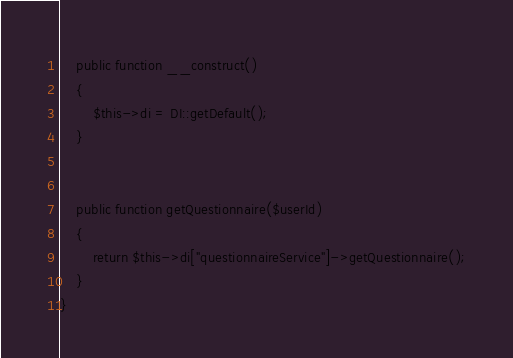<code> <loc_0><loc_0><loc_500><loc_500><_PHP_>    public function __construct()
    {
        $this->di = DI::getDefault();
    }


    public function getQuestionnaire($userId)
    {
        return $this->di["questionnaireService"]->getQuestionnaire();
    }
}</code> 